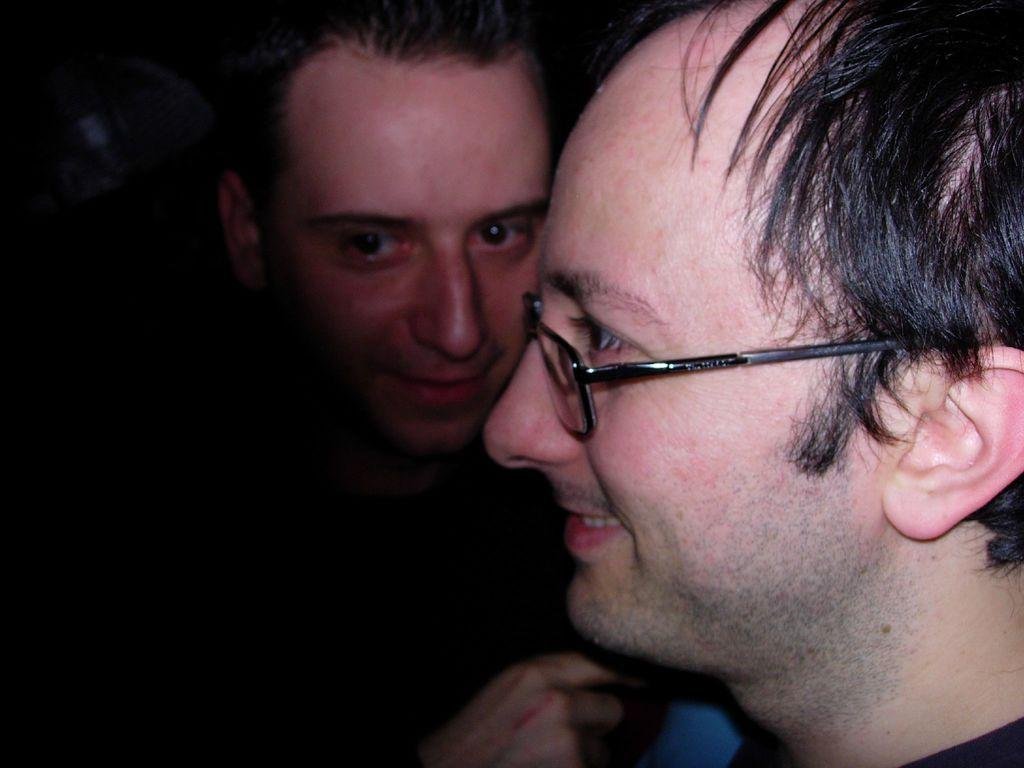How many people are visible on the right side of the image? There are two men on the right side of the image. What is the lighting condition on the left side of the image? The left side of the image is dark. What color is the hair of the man on the left side of the image? There is no man on the left side of the image, as it is dark. How many chairs are visible in the image? There is no information about chairs in the provided facts, so we cannot determine how many chairs are visible in the image. 